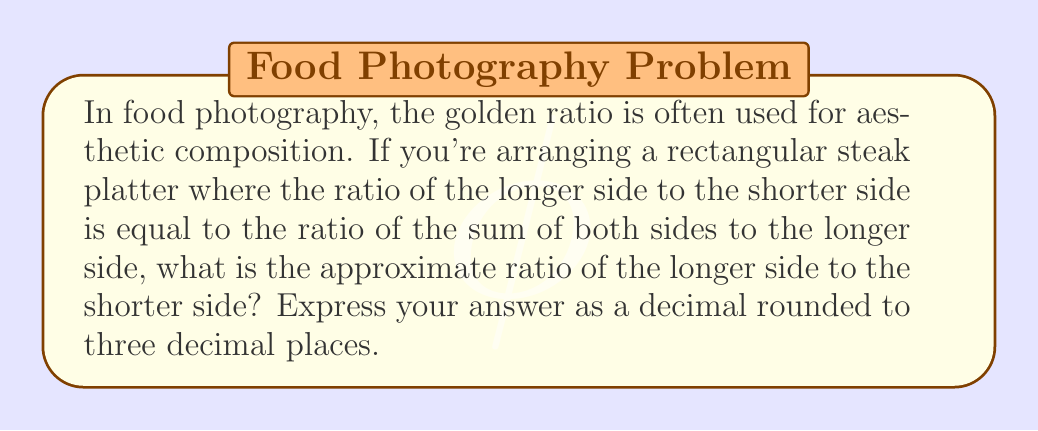Can you solve this math problem? Let's approach this step-by-step:

1) Let's denote the shorter side of the rectangle as $a$ and the longer side as $b$.

2) According to the golden ratio principle, we can write:

   $$\frac{b}{a} = \frac{a+b}{b}$$

3) This can be rewritten as:

   $$b^2 = a(a+b)$$

4) Expanding the right side:

   $$b^2 = a^2 + ab$$

5) Subtracting $ab$ from both sides:

   $$b^2 - ab = a^2$$

6) Factoring out $b$ from the left side:

   $$b(b - a) = a^2$$

7) Dividing both sides by $a^2$:

   $$\frac{b}{a}(\frac{b}{a} - 1) = 1$$

8) Let $x = \frac{b}{a}$. Then we have:

   $$x(x - 1) = 1$$

9) Expanding:

   $$x^2 - x - 1 = 0$$

10) This is a quadratic equation. We can solve it using the quadratic formula:

    $$x = \frac{-b \pm \sqrt{b^2 - 4ac}}{2a}$$

    where $a=1$, $b=-1$, and $c=-1$

11) Plugging in these values:

    $$x = \frac{1 \pm \sqrt{1 - 4(1)(-1)}}{2(1)} = \frac{1 \pm \sqrt{5}}{2}$$

12) We take the positive solution as we're dealing with a ratio:

    $$x = \frac{1 + \sqrt{5}}{2} \approx 1.618033989$$

13) Rounding to three decimal places:

    $$x \approx 1.618$$

This ratio, known as the golden ratio or φ (phi), is approximately 1.618.
Answer: 1.618 